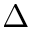Convert formula to latex. <formula><loc_0><loc_0><loc_500><loc_500>\Delta</formula> 